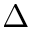Convert formula to latex. <formula><loc_0><loc_0><loc_500><loc_500>\Delta</formula> 